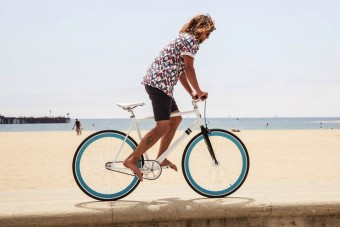Could this location be suitable for a family outing? Absolutely, the spacious sandy beach and the calm sea make it an ideal location for a family outing, offering various activities such as cycling, swimming, and sunbathing. What facilities might be nearby to support such activities? Typically, seaside promenades like this one may have facilities such as restrooms, showers, rental kiosks for bikes and water sports equipment, picnic areas, and nearby restaurants or cafes. 